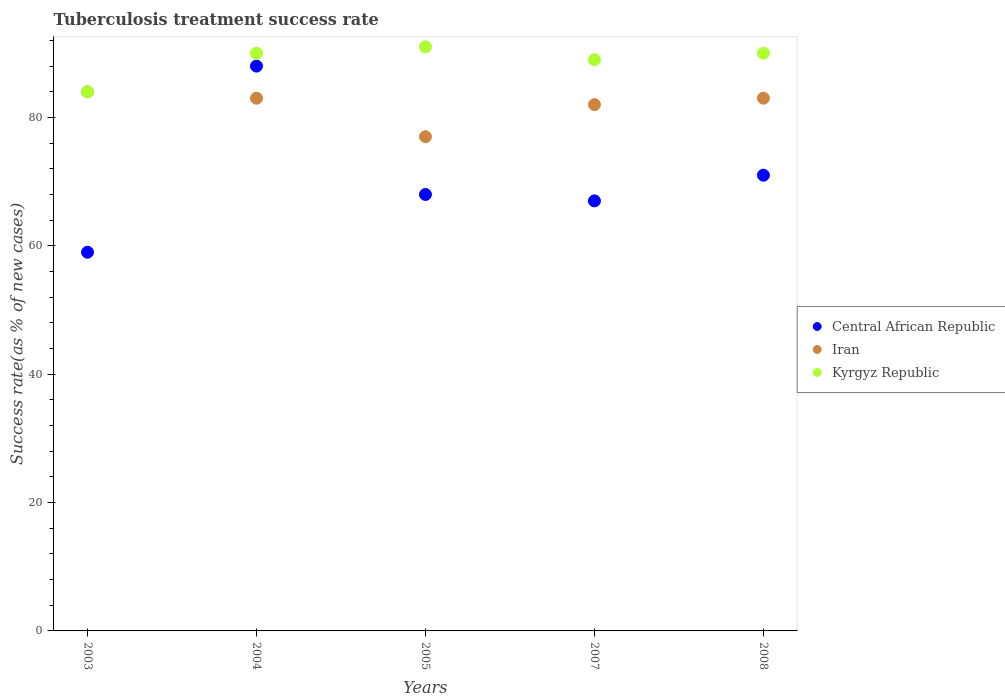How many different coloured dotlines are there?
Your answer should be compact. 3. What is the tuberculosis treatment success rate in Central African Republic in 2007?
Ensure brevity in your answer.  67. Across all years, what is the maximum tuberculosis treatment success rate in Kyrgyz Republic?
Give a very brief answer. 91. Across all years, what is the minimum tuberculosis treatment success rate in Kyrgyz Republic?
Provide a short and direct response. 84. In which year was the tuberculosis treatment success rate in Kyrgyz Republic maximum?
Provide a short and direct response. 2005. What is the total tuberculosis treatment success rate in Central African Republic in the graph?
Keep it short and to the point. 353. What is the difference between the tuberculosis treatment success rate in Kyrgyz Republic in 2005 and the tuberculosis treatment success rate in Iran in 2007?
Offer a very short reply. 9. What is the average tuberculosis treatment success rate in Central African Republic per year?
Offer a very short reply. 70.6. In how many years, is the tuberculosis treatment success rate in Iran greater than 16 %?
Offer a very short reply. 5. What is the ratio of the tuberculosis treatment success rate in Kyrgyz Republic in 2003 to that in 2004?
Your answer should be compact. 0.93. Is the difference between the tuberculosis treatment success rate in Kyrgyz Republic in 2004 and 2008 greater than the difference between the tuberculosis treatment success rate in Iran in 2004 and 2008?
Provide a succinct answer. No. In how many years, is the tuberculosis treatment success rate in Kyrgyz Republic greater than the average tuberculosis treatment success rate in Kyrgyz Republic taken over all years?
Your answer should be compact. 4. Is the sum of the tuberculosis treatment success rate in Kyrgyz Republic in 2004 and 2007 greater than the maximum tuberculosis treatment success rate in Central African Republic across all years?
Your answer should be very brief. Yes. Is it the case that in every year, the sum of the tuberculosis treatment success rate in Iran and tuberculosis treatment success rate in Kyrgyz Republic  is greater than the tuberculosis treatment success rate in Central African Republic?
Provide a succinct answer. Yes. Does the graph contain grids?
Give a very brief answer. No. How many legend labels are there?
Offer a terse response. 3. How are the legend labels stacked?
Offer a terse response. Vertical. What is the title of the graph?
Make the answer very short. Tuberculosis treatment success rate. What is the label or title of the X-axis?
Your answer should be very brief. Years. What is the label or title of the Y-axis?
Provide a succinct answer. Success rate(as % of new cases). What is the Success rate(as % of new cases) of Iran in 2004?
Your answer should be compact. 83. What is the Success rate(as % of new cases) in Central African Republic in 2005?
Offer a terse response. 68. What is the Success rate(as % of new cases) of Iran in 2005?
Offer a very short reply. 77. What is the Success rate(as % of new cases) of Kyrgyz Republic in 2005?
Your answer should be compact. 91. What is the Success rate(as % of new cases) in Central African Republic in 2007?
Make the answer very short. 67. What is the Success rate(as % of new cases) of Kyrgyz Republic in 2007?
Offer a very short reply. 89. What is the Success rate(as % of new cases) of Iran in 2008?
Your response must be concise. 83. What is the Success rate(as % of new cases) of Kyrgyz Republic in 2008?
Offer a very short reply. 90. Across all years, what is the maximum Success rate(as % of new cases) of Kyrgyz Republic?
Provide a short and direct response. 91. What is the total Success rate(as % of new cases) of Central African Republic in the graph?
Make the answer very short. 353. What is the total Success rate(as % of new cases) of Iran in the graph?
Your answer should be compact. 409. What is the total Success rate(as % of new cases) of Kyrgyz Republic in the graph?
Give a very brief answer. 444. What is the difference between the Success rate(as % of new cases) of Central African Republic in 2003 and that in 2005?
Provide a short and direct response. -9. What is the difference between the Success rate(as % of new cases) in Iran in 2003 and that in 2005?
Provide a succinct answer. 7. What is the difference between the Success rate(as % of new cases) in Kyrgyz Republic in 2003 and that in 2005?
Give a very brief answer. -7. What is the difference between the Success rate(as % of new cases) of Central African Republic in 2003 and that in 2007?
Give a very brief answer. -8. What is the difference between the Success rate(as % of new cases) of Iran in 2003 and that in 2008?
Ensure brevity in your answer.  1. What is the difference between the Success rate(as % of new cases) in Kyrgyz Republic in 2003 and that in 2008?
Offer a terse response. -6. What is the difference between the Success rate(as % of new cases) in Central African Republic in 2004 and that in 2005?
Your response must be concise. 20. What is the difference between the Success rate(as % of new cases) in Kyrgyz Republic in 2004 and that in 2005?
Offer a terse response. -1. What is the difference between the Success rate(as % of new cases) in Iran in 2004 and that in 2007?
Offer a very short reply. 1. What is the difference between the Success rate(as % of new cases) of Central African Republic in 2004 and that in 2008?
Make the answer very short. 17. What is the difference between the Success rate(as % of new cases) of Iran in 2004 and that in 2008?
Your response must be concise. 0. What is the difference between the Success rate(as % of new cases) in Iran in 2005 and that in 2007?
Your response must be concise. -5. What is the difference between the Success rate(as % of new cases) in Kyrgyz Republic in 2005 and that in 2007?
Keep it short and to the point. 2. What is the difference between the Success rate(as % of new cases) in Iran in 2007 and that in 2008?
Provide a short and direct response. -1. What is the difference between the Success rate(as % of new cases) of Central African Republic in 2003 and the Success rate(as % of new cases) of Kyrgyz Republic in 2004?
Offer a terse response. -31. What is the difference between the Success rate(as % of new cases) of Iran in 2003 and the Success rate(as % of new cases) of Kyrgyz Republic in 2004?
Offer a very short reply. -6. What is the difference between the Success rate(as % of new cases) of Central African Republic in 2003 and the Success rate(as % of new cases) of Iran in 2005?
Your answer should be very brief. -18. What is the difference between the Success rate(as % of new cases) of Central African Republic in 2003 and the Success rate(as % of new cases) of Kyrgyz Republic in 2005?
Offer a terse response. -32. What is the difference between the Success rate(as % of new cases) in Central African Republic in 2003 and the Success rate(as % of new cases) in Iran in 2007?
Your answer should be compact. -23. What is the difference between the Success rate(as % of new cases) in Central African Republic in 2003 and the Success rate(as % of new cases) in Kyrgyz Republic in 2007?
Provide a succinct answer. -30. What is the difference between the Success rate(as % of new cases) of Iran in 2003 and the Success rate(as % of new cases) of Kyrgyz Republic in 2007?
Provide a short and direct response. -5. What is the difference between the Success rate(as % of new cases) of Central African Republic in 2003 and the Success rate(as % of new cases) of Iran in 2008?
Provide a short and direct response. -24. What is the difference between the Success rate(as % of new cases) in Central African Republic in 2003 and the Success rate(as % of new cases) in Kyrgyz Republic in 2008?
Give a very brief answer. -31. What is the difference between the Success rate(as % of new cases) of Central African Republic in 2004 and the Success rate(as % of new cases) of Iran in 2005?
Provide a succinct answer. 11. What is the difference between the Success rate(as % of new cases) in Central African Republic in 2004 and the Success rate(as % of new cases) in Kyrgyz Republic in 2005?
Your answer should be very brief. -3. What is the difference between the Success rate(as % of new cases) in Central African Republic in 2004 and the Success rate(as % of new cases) in Iran in 2007?
Make the answer very short. 6. What is the difference between the Success rate(as % of new cases) in Iran in 2004 and the Success rate(as % of new cases) in Kyrgyz Republic in 2008?
Offer a terse response. -7. What is the difference between the Success rate(as % of new cases) in Iran in 2005 and the Success rate(as % of new cases) in Kyrgyz Republic in 2007?
Provide a short and direct response. -12. What is the difference between the Success rate(as % of new cases) in Central African Republic in 2005 and the Success rate(as % of new cases) in Iran in 2008?
Provide a short and direct response. -15. What is the difference between the Success rate(as % of new cases) of Central African Republic in 2007 and the Success rate(as % of new cases) of Iran in 2008?
Your response must be concise. -16. What is the difference between the Success rate(as % of new cases) in Central African Republic in 2007 and the Success rate(as % of new cases) in Kyrgyz Republic in 2008?
Provide a succinct answer. -23. What is the difference between the Success rate(as % of new cases) in Iran in 2007 and the Success rate(as % of new cases) in Kyrgyz Republic in 2008?
Give a very brief answer. -8. What is the average Success rate(as % of new cases) in Central African Republic per year?
Your response must be concise. 70.6. What is the average Success rate(as % of new cases) in Iran per year?
Provide a short and direct response. 81.8. What is the average Success rate(as % of new cases) of Kyrgyz Republic per year?
Offer a terse response. 88.8. In the year 2003, what is the difference between the Success rate(as % of new cases) in Central African Republic and Success rate(as % of new cases) in Iran?
Ensure brevity in your answer.  -25. In the year 2003, what is the difference between the Success rate(as % of new cases) of Central African Republic and Success rate(as % of new cases) of Kyrgyz Republic?
Keep it short and to the point. -25. In the year 2004, what is the difference between the Success rate(as % of new cases) in Central African Republic and Success rate(as % of new cases) in Iran?
Offer a very short reply. 5. In the year 2005, what is the difference between the Success rate(as % of new cases) of Central African Republic and Success rate(as % of new cases) of Iran?
Ensure brevity in your answer.  -9. In the year 2008, what is the difference between the Success rate(as % of new cases) in Central African Republic and Success rate(as % of new cases) in Iran?
Provide a succinct answer. -12. In the year 2008, what is the difference between the Success rate(as % of new cases) in Iran and Success rate(as % of new cases) in Kyrgyz Republic?
Make the answer very short. -7. What is the ratio of the Success rate(as % of new cases) in Central African Republic in 2003 to that in 2004?
Provide a succinct answer. 0.67. What is the ratio of the Success rate(as % of new cases) of Kyrgyz Republic in 2003 to that in 2004?
Your answer should be very brief. 0.93. What is the ratio of the Success rate(as % of new cases) in Central African Republic in 2003 to that in 2005?
Your answer should be compact. 0.87. What is the ratio of the Success rate(as % of new cases) of Iran in 2003 to that in 2005?
Offer a very short reply. 1.09. What is the ratio of the Success rate(as % of new cases) of Kyrgyz Republic in 2003 to that in 2005?
Offer a very short reply. 0.92. What is the ratio of the Success rate(as % of new cases) of Central African Republic in 2003 to that in 2007?
Make the answer very short. 0.88. What is the ratio of the Success rate(as % of new cases) of Iran in 2003 to that in 2007?
Give a very brief answer. 1.02. What is the ratio of the Success rate(as % of new cases) in Kyrgyz Republic in 2003 to that in 2007?
Ensure brevity in your answer.  0.94. What is the ratio of the Success rate(as % of new cases) of Central African Republic in 2003 to that in 2008?
Ensure brevity in your answer.  0.83. What is the ratio of the Success rate(as % of new cases) of Iran in 2003 to that in 2008?
Make the answer very short. 1.01. What is the ratio of the Success rate(as % of new cases) in Kyrgyz Republic in 2003 to that in 2008?
Provide a short and direct response. 0.93. What is the ratio of the Success rate(as % of new cases) of Central African Republic in 2004 to that in 2005?
Your answer should be very brief. 1.29. What is the ratio of the Success rate(as % of new cases) in Iran in 2004 to that in 2005?
Your answer should be compact. 1.08. What is the ratio of the Success rate(as % of new cases) of Kyrgyz Republic in 2004 to that in 2005?
Make the answer very short. 0.99. What is the ratio of the Success rate(as % of new cases) of Central African Republic in 2004 to that in 2007?
Ensure brevity in your answer.  1.31. What is the ratio of the Success rate(as % of new cases) of Iran in 2004 to that in 2007?
Your response must be concise. 1.01. What is the ratio of the Success rate(as % of new cases) in Kyrgyz Republic in 2004 to that in 2007?
Offer a terse response. 1.01. What is the ratio of the Success rate(as % of new cases) of Central African Republic in 2004 to that in 2008?
Provide a short and direct response. 1.24. What is the ratio of the Success rate(as % of new cases) of Central African Republic in 2005 to that in 2007?
Give a very brief answer. 1.01. What is the ratio of the Success rate(as % of new cases) of Iran in 2005 to that in 2007?
Provide a short and direct response. 0.94. What is the ratio of the Success rate(as % of new cases) of Kyrgyz Republic in 2005 to that in 2007?
Provide a short and direct response. 1.02. What is the ratio of the Success rate(as % of new cases) of Central African Republic in 2005 to that in 2008?
Ensure brevity in your answer.  0.96. What is the ratio of the Success rate(as % of new cases) in Iran in 2005 to that in 2008?
Provide a short and direct response. 0.93. What is the ratio of the Success rate(as % of new cases) in Kyrgyz Republic in 2005 to that in 2008?
Keep it short and to the point. 1.01. What is the ratio of the Success rate(as % of new cases) in Central African Republic in 2007 to that in 2008?
Offer a very short reply. 0.94. What is the ratio of the Success rate(as % of new cases) in Iran in 2007 to that in 2008?
Offer a very short reply. 0.99. What is the ratio of the Success rate(as % of new cases) in Kyrgyz Republic in 2007 to that in 2008?
Your response must be concise. 0.99. What is the difference between the highest and the second highest Success rate(as % of new cases) in Kyrgyz Republic?
Ensure brevity in your answer.  1. What is the difference between the highest and the lowest Success rate(as % of new cases) of Iran?
Your response must be concise. 7. What is the difference between the highest and the lowest Success rate(as % of new cases) in Kyrgyz Republic?
Provide a succinct answer. 7. 